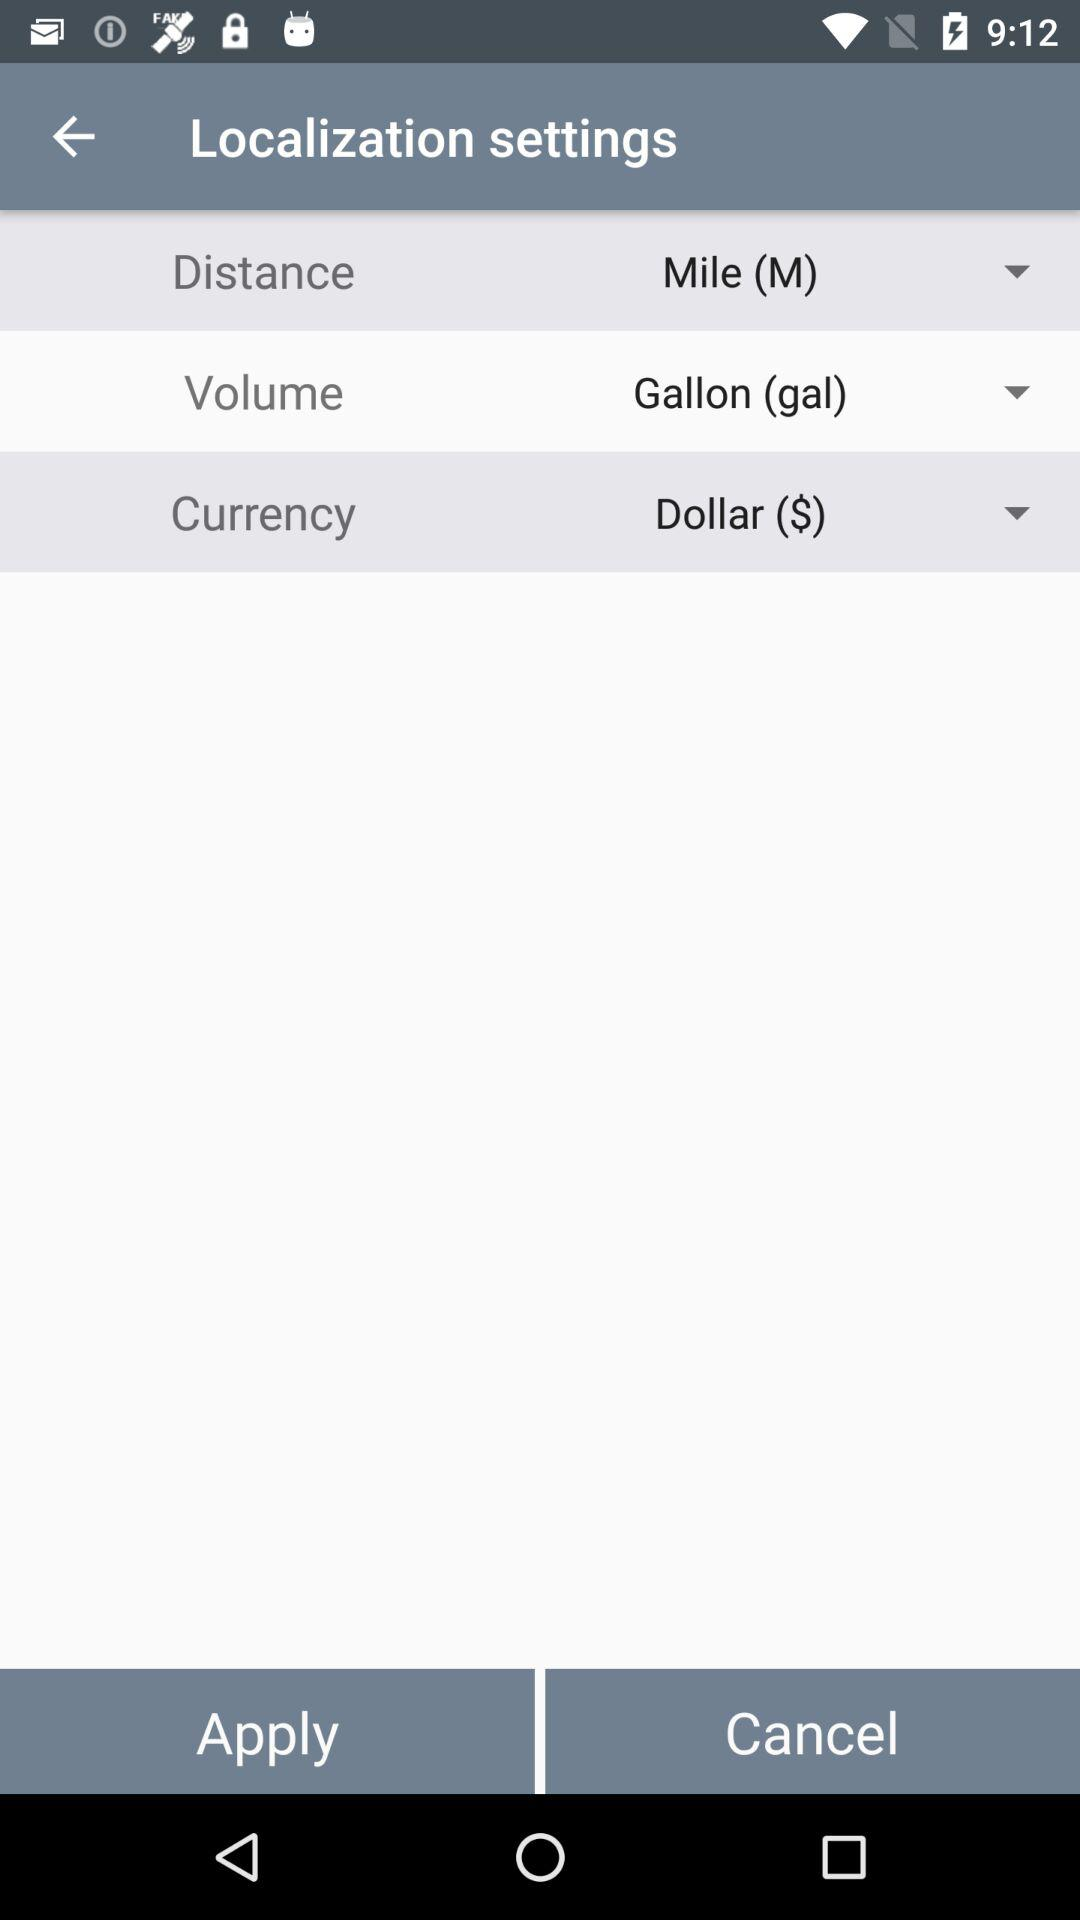What is the selected unit of distance? The selected unit of distance is the mile. 